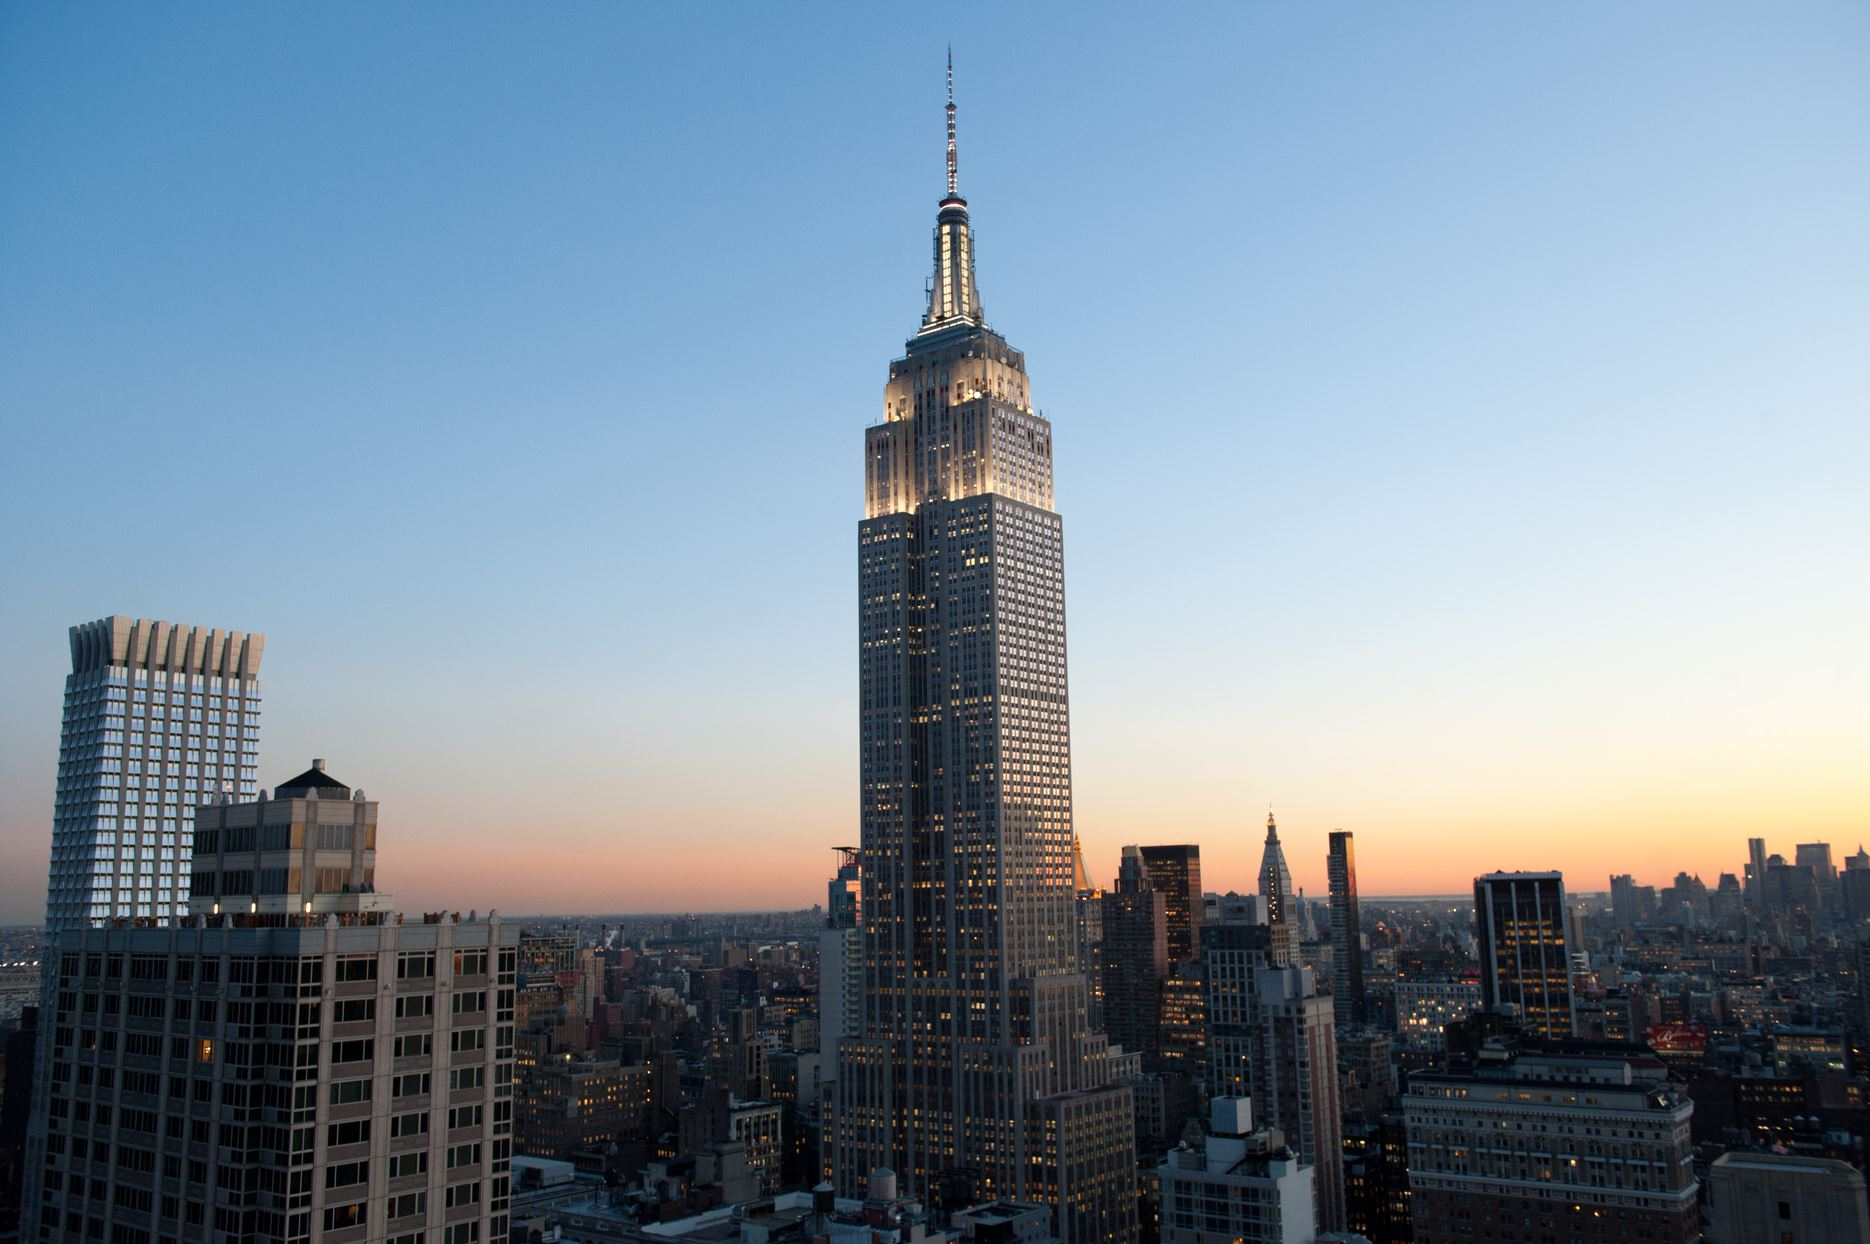What stories do the lights in the windows of the buildings tell? The myriad of lights in the windows of the buildings tell countless stories of the lives within. Each light represents a unique individual with their own experiences, ambitions, and routines. In some windows, the lights might indicate people returning home after a long day, enjoying family meals, or indulging in their hobbies. In others, the lights reflect offices buzzing with late-night work, ideas being brainstormed, and businesses in operation. The diversity and vibrancy of New York City are encapsulated in these lights, painting a vivid picture of a city that breathes life, energy, and endless possibilities around the clock. Imagine a fantastical scenario occurring in this cityscape. Describe it in detail. As night takes over and the city begins to settle, a phenomenon never before seen takes place. The lights in the windows start to flicker rhythmically, forming patterns and pulsating like the heartbeat of the city. Suddenly, the Empire State Building begins to glow more intensely, emitting a soft hum. The glow spreads through the grid of buildings like a wave, causing a bioluminescent transformation. Trees, parks, and rooftops erupt with vibrant, glowing flora, stemming from an ancient seed buried deep within the city’s foundation. As the phenomenon progresses, fantastical beings emerge from the shadows, blending with the urban dwellers without causing alarm. The city becomes a living entity, where reality and fantasy merge seamlessly. This surreal and magical event leaves the city dwellers in awe, pondering if it was a dream or a mystical experience brought by the unity between human creations and the wonders of nature. How do the tall buildings impact the daily life of NYC residents? The tall buildings in NYC significantly shape the daily lives of its residents. They provide a verticality that maximizes limited space, supporting both commercial and residential needs. For many, these skyscrapers house their offices, making them vital centers of business and employment. Living in high-rise apartments offers expansive views of the city, contributing to a unique urban lifestyle and culture. However, the towering structures also mean that sunlight can be limited in some areas, affecting natural light exposure. Additionally, these buildings support the efficient usage of public transportation and facilitate the hosting of numerous amenities and services within accessible distances, enhancing the interconnectedness and convenience for city residents. Describe an ordinary evening in the life of a resident. On an ordinary evening in NYC, residents might be returning home from work, navigating through the bustling streets or crowded subway stations. As they enter their high-rise apartments, some might be greeted by a breathtaking view of the city skyline shimmering under the twilight. Families come together to share dinner, while others might engage in various activities such as unwinding with a book, working out in the building’s gym, or socializing over drinks in local cafes or bars. As night falls, the city remains alive; lights flicker on, illuminating the streets with a warm glow, and the sounds of life – conversations, laughter, and distant sirens – fuse into the ambient urban symphony. The energy of the city doesn’t diminish, it merely shifts into a more relaxed but ever-present hum. 